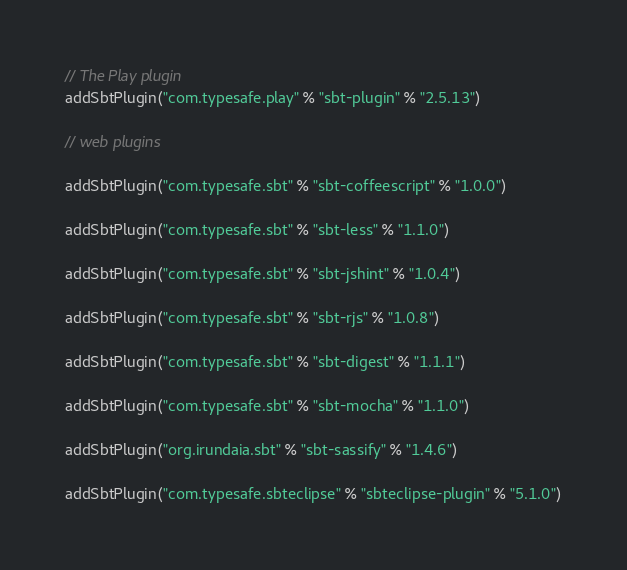Convert code to text. <code><loc_0><loc_0><loc_500><loc_500><_Scala_>// The Play plugin
addSbtPlugin("com.typesafe.play" % "sbt-plugin" % "2.5.13")

// web plugins

addSbtPlugin("com.typesafe.sbt" % "sbt-coffeescript" % "1.0.0")

addSbtPlugin("com.typesafe.sbt" % "sbt-less" % "1.1.0")

addSbtPlugin("com.typesafe.sbt" % "sbt-jshint" % "1.0.4")

addSbtPlugin("com.typesafe.sbt" % "sbt-rjs" % "1.0.8")

addSbtPlugin("com.typesafe.sbt" % "sbt-digest" % "1.1.1")

addSbtPlugin("com.typesafe.sbt" % "sbt-mocha" % "1.1.0")

addSbtPlugin("org.irundaia.sbt" % "sbt-sassify" % "1.4.6")

addSbtPlugin("com.typesafe.sbteclipse" % "sbteclipse-plugin" % "5.1.0")
</code> 